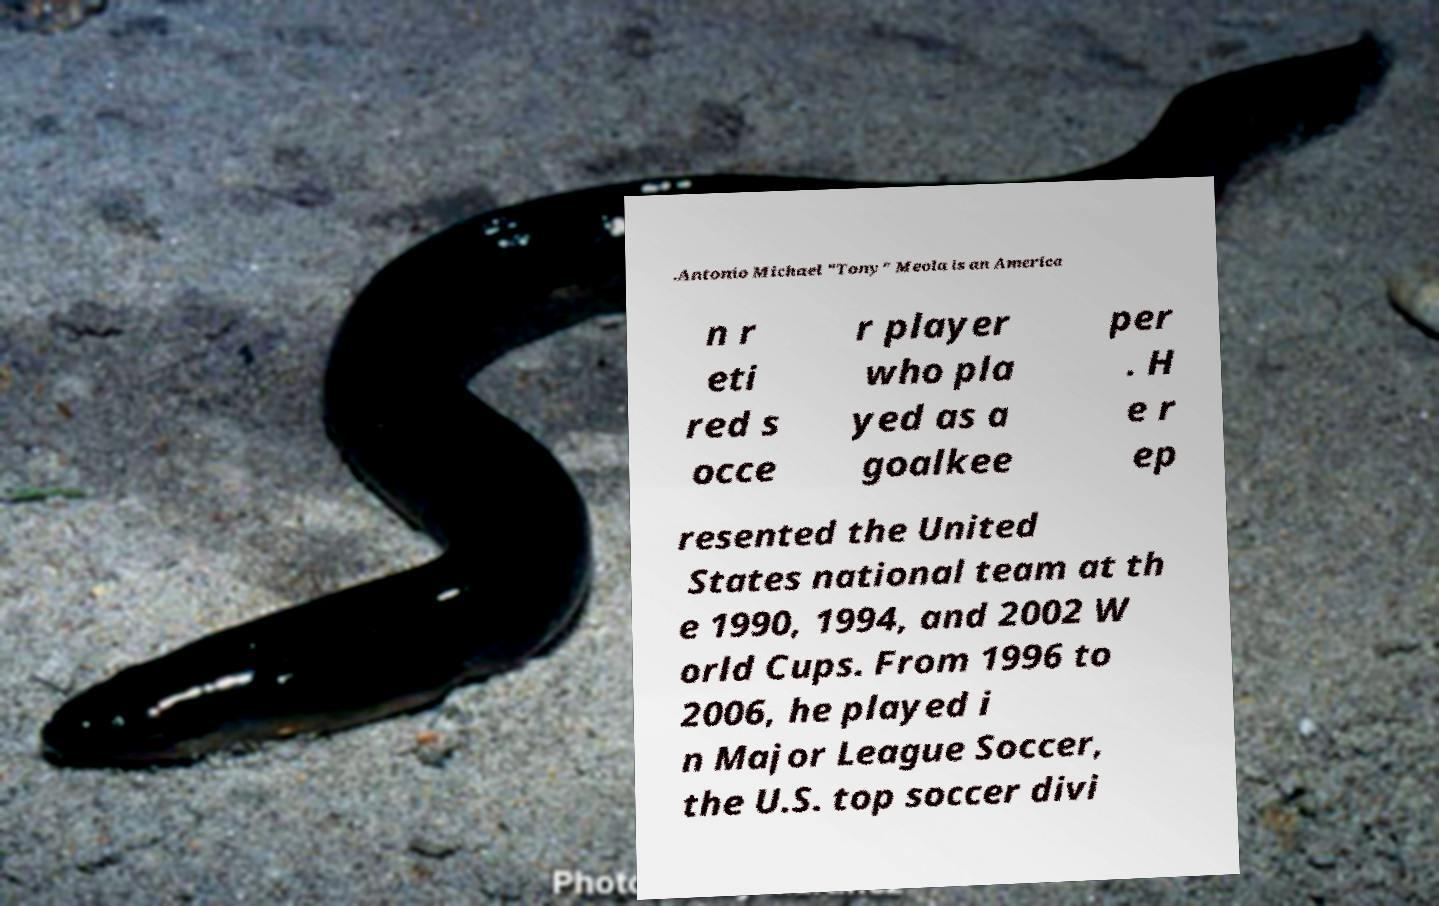There's text embedded in this image that I need extracted. Can you transcribe it verbatim? .Antonio Michael "Tony" Meola is an America n r eti red s occe r player who pla yed as a goalkee per . H e r ep resented the United States national team at th e 1990, 1994, and 2002 W orld Cups. From 1996 to 2006, he played i n Major League Soccer, the U.S. top soccer divi 